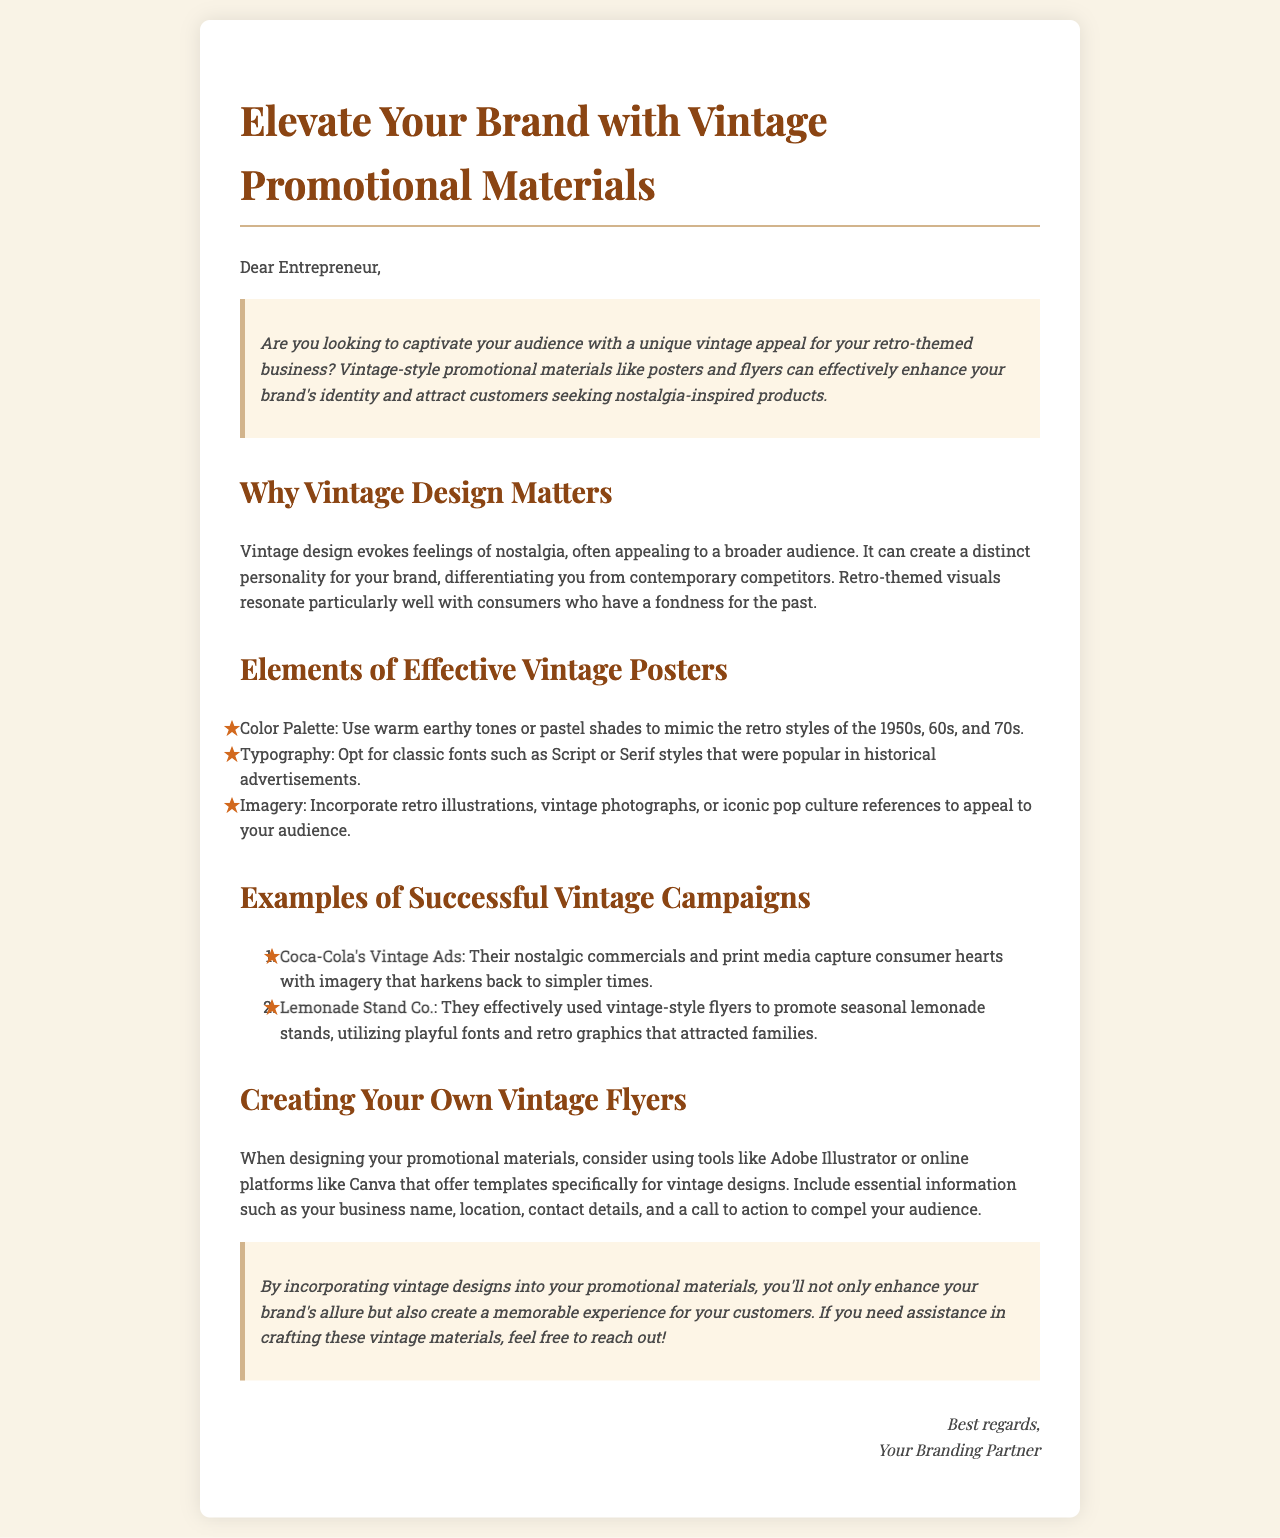What is the title of the document? The title of the document is indicated in the HTML title tag.
Answer: Vintage Promotional Materials What are two elements of effective vintage posters? The document lists color palette and typography as elements of effective vintage posters.
Answer: Color Palette, Typography What is the promotion strategy used by Lemonade Stand Co.? The document describes how Lemonade Stand Co. used vintage-style flyers to attract families.
Answer: Vintage-style flyers Which fonts are suggested for vintage typography? The document mentions classic fonts such as Script or Serif styles.
Answer: Script or Serif What does the section "Creating Your Own Vintage Flyers" suggest using for design? The document recommends using Adobe Illustrator or online platforms like Canva for designing promotional materials.
Answer: Adobe Illustrator, Canva What type of appeals does vintage design evoke? The document states that vintage design evokes feelings of nostalgia.
Answer: Nostalgia How many examples of successful vintage campaigns are provided? The document lists two examples of successful vintage campaigns.
Answer: Two What is a call to action suggested in the promotional materials? The document implies including a call to action to compel your audience in the flyers.
Answer: Call to action What color scheme is encouraged for vintage designs? The document suggests using warm earthy tones or pastel shades for the color palette.
Answer: Warm earthy tones, pastel shades 